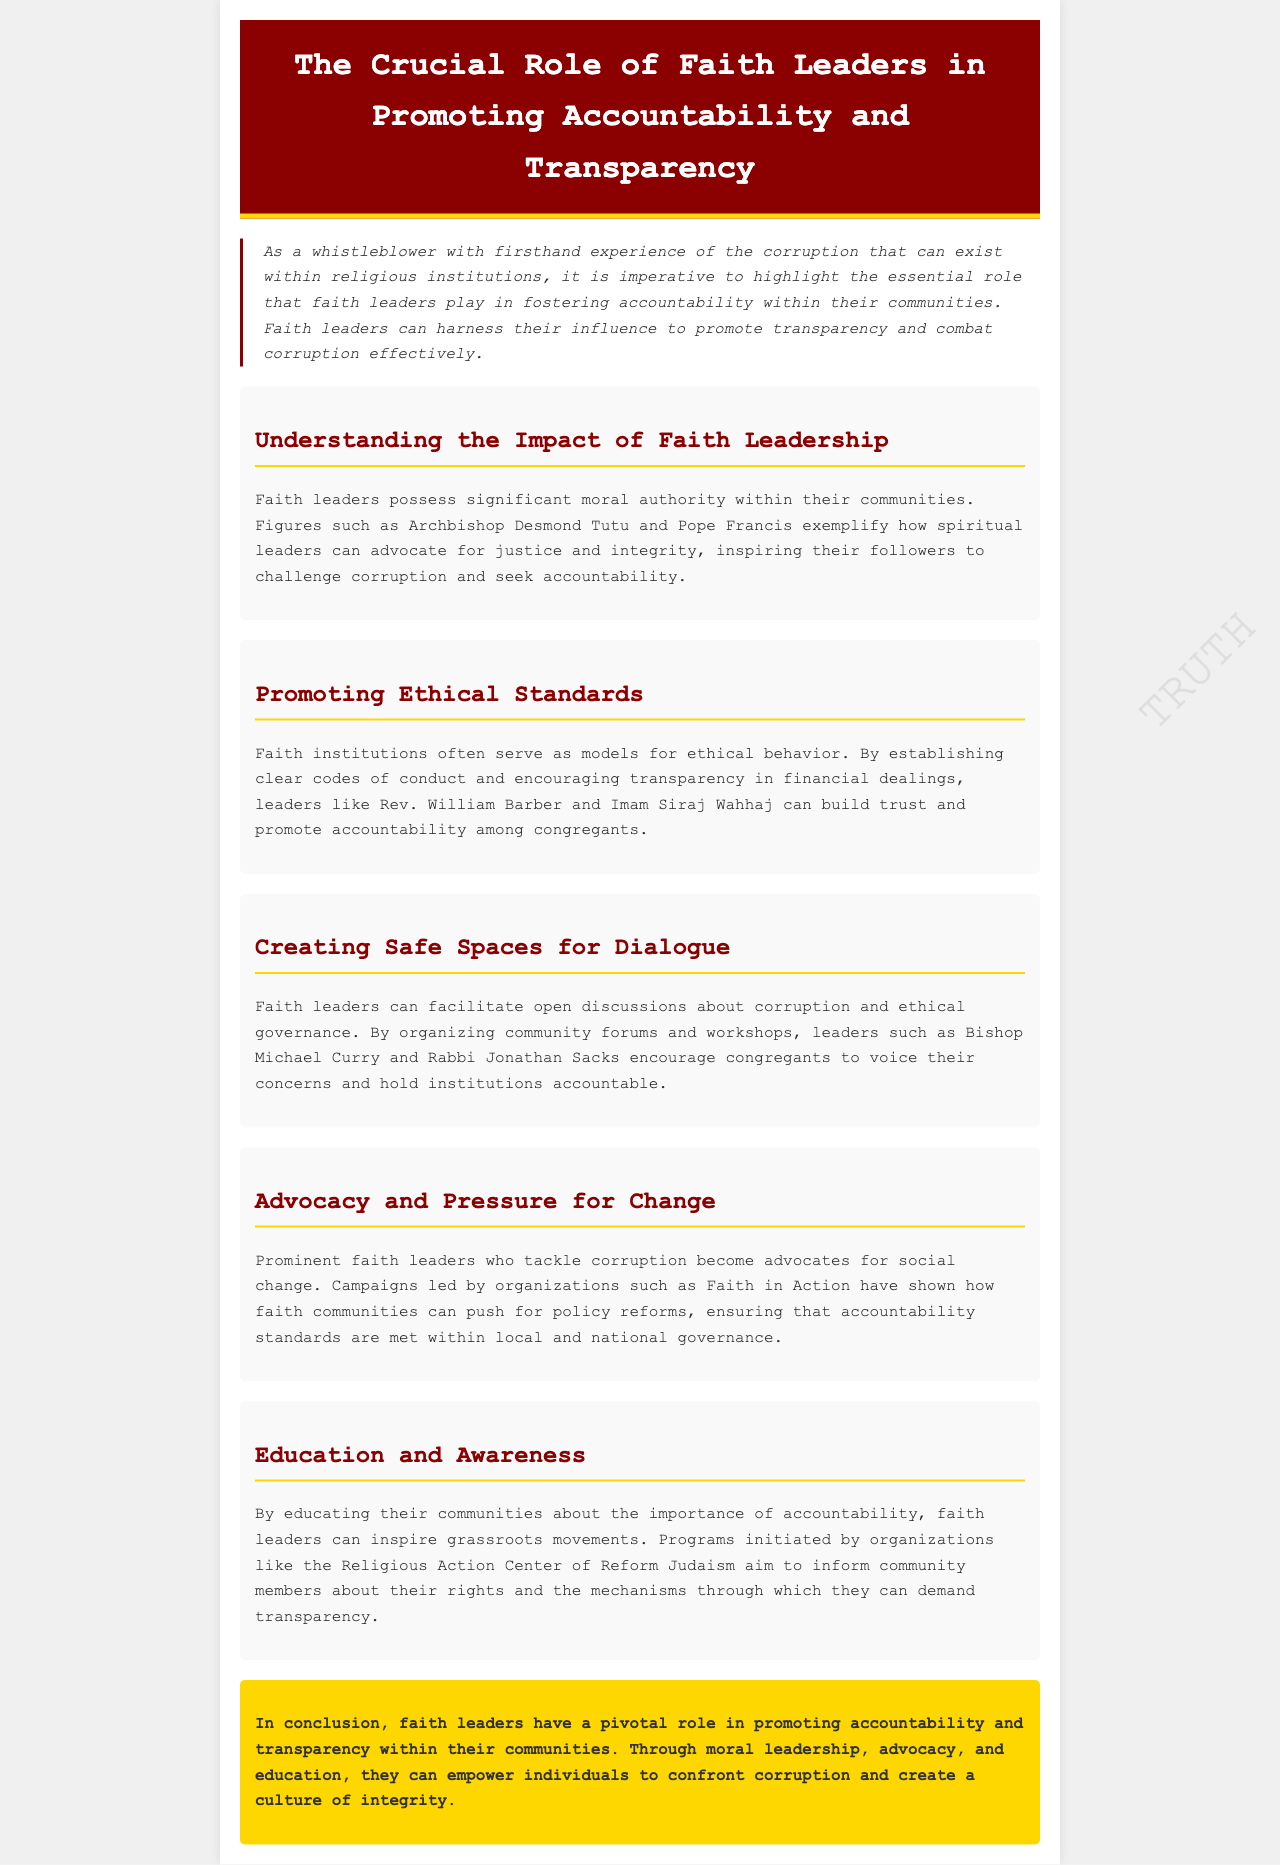what is the title of the newsletter? The title is explicitly stated in the header of the document.
Answer: The Crucial Role of Faith Leaders in Promoting Accountability and Transparency who exemplifies how spiritual leaders can advocate for justice? The document mentions specific figures known for their advocacy in its text.
Answer: Archbishop Desmond Tutu what do faith institutions establish to promote ethical behavior? This information relates to the ethical standards section of the document, highlighting expected practices.
Answer: Clear codes of conduct which community forum type is mentioned as a method to discuss corruption? The document describes methods utilized by leaders to discuss accountability.
Answer: Community forums who leads campaigns shown to push for policy reforms? This question targets organizations highlighted for their advocacy work in the text.
Answer: Faith in Action what is one way faith leaders educate their communities? The document outlines educational programs that inform community members about accountability.
Answer: Programs initiated by organizations how do faith leaders contribute to accountability within their communities? This question requires synthesizing the newsletter's overall message and themes.
Answer: Moral leadership, advocacy, and education who organized workshops to encourage open discussions? This question identifies individuals recognized for their contributions mentioned in the document.
Answer: Bishop Michael Curry 